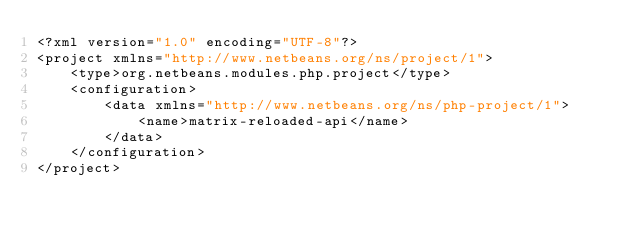<code> <loc_0><loc_0><loc_500><loc_500><_XML_><?xml version="1.0" encoding="UTF-8"?>
<project xmlns="http://www.netbeans.org/ns/project/1">
    <type>org.netbeans.modules.php.project</type>
    <configuration>
        <data xmlns="http://www.netbeans.org/ns/php-project/1">
            <name>matrix-reloaded-api</name>
        </data>
    </configuration>
</project>
</code> 